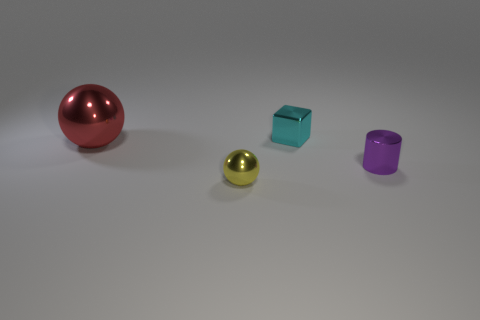Subtract all cylinders. How many objects are left? 3 Subtract 1 cubes. How many cubes are left? 0 Subtract all red spheres. How many spheres are left? 1 Add 4 small shiny balls. How many small shiny balls are left? 5 Add 4 cubes. How many cubes exist? 5 Add 1 large green things. How many objects exist? 5 Subtract 0 green balls. How many objects are left? 4 Subtract all blue cubes. Subtract all red cylinders. How many cubes are left? 1 Subtract all gray cylinders. How many red balls are left? 1 Subtract all red things. Subtract all matte cylinders. How many objects are left? 3 